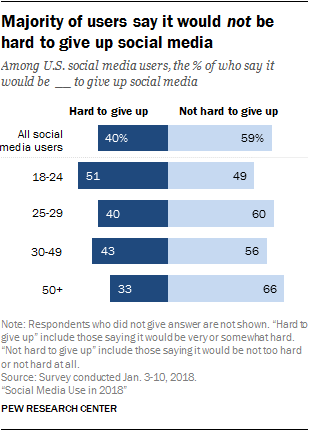Identify some key points in this picture. The value of the lowest blue bar is 33. What is the difference between the highest and lowest light blue bar in the graph? 